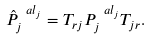Convert formula to latex. <formula><loc_0><loc_0><loc_500><loc_500>\hat { P } ^ { \ a l _ { j } } _ { j } = T _ { r j } P ^ { \ a l _ { j } } _ { j } T _ { j r } .</formula> 